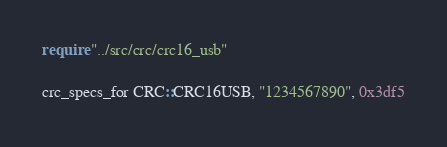Convert code to text. <code><loc_0><loc_0><loc_500><loc_500><_Crystal_>require "../src/crc/crc16_usb"

crc_specs_for CRC::CRC16USB, "1234567890", 0x3df5
</code> 